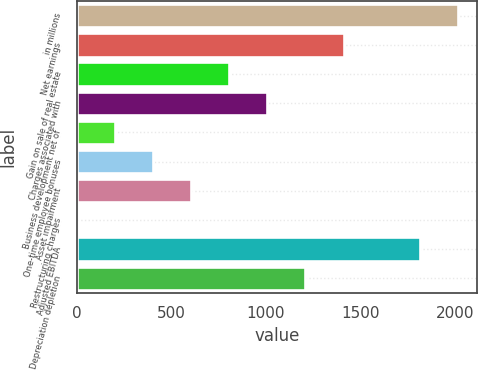<chart> <loc_0><loc_0><loc_500><loc_500><bar_chart><fcel>in millions<fcel>Net earnings<fcel>Gain on sale of real estate<fcel>Charges associated with<fcel>Business development net of<fcel>One-time employee bonuses<fcel>Asset impairment<fcel>Restructuring charges<fcel>Adjusted EBITDA<fcel>Depreciation depletion<nl><fcel>2016<fcel>1411.29<fcel>806.58<fcel>1008.15<fcel>201.87<fcel>403.44<fcel>605.01<fcel>0.3<fcel>1814.43<fcel>1209.72<nl></chart> 